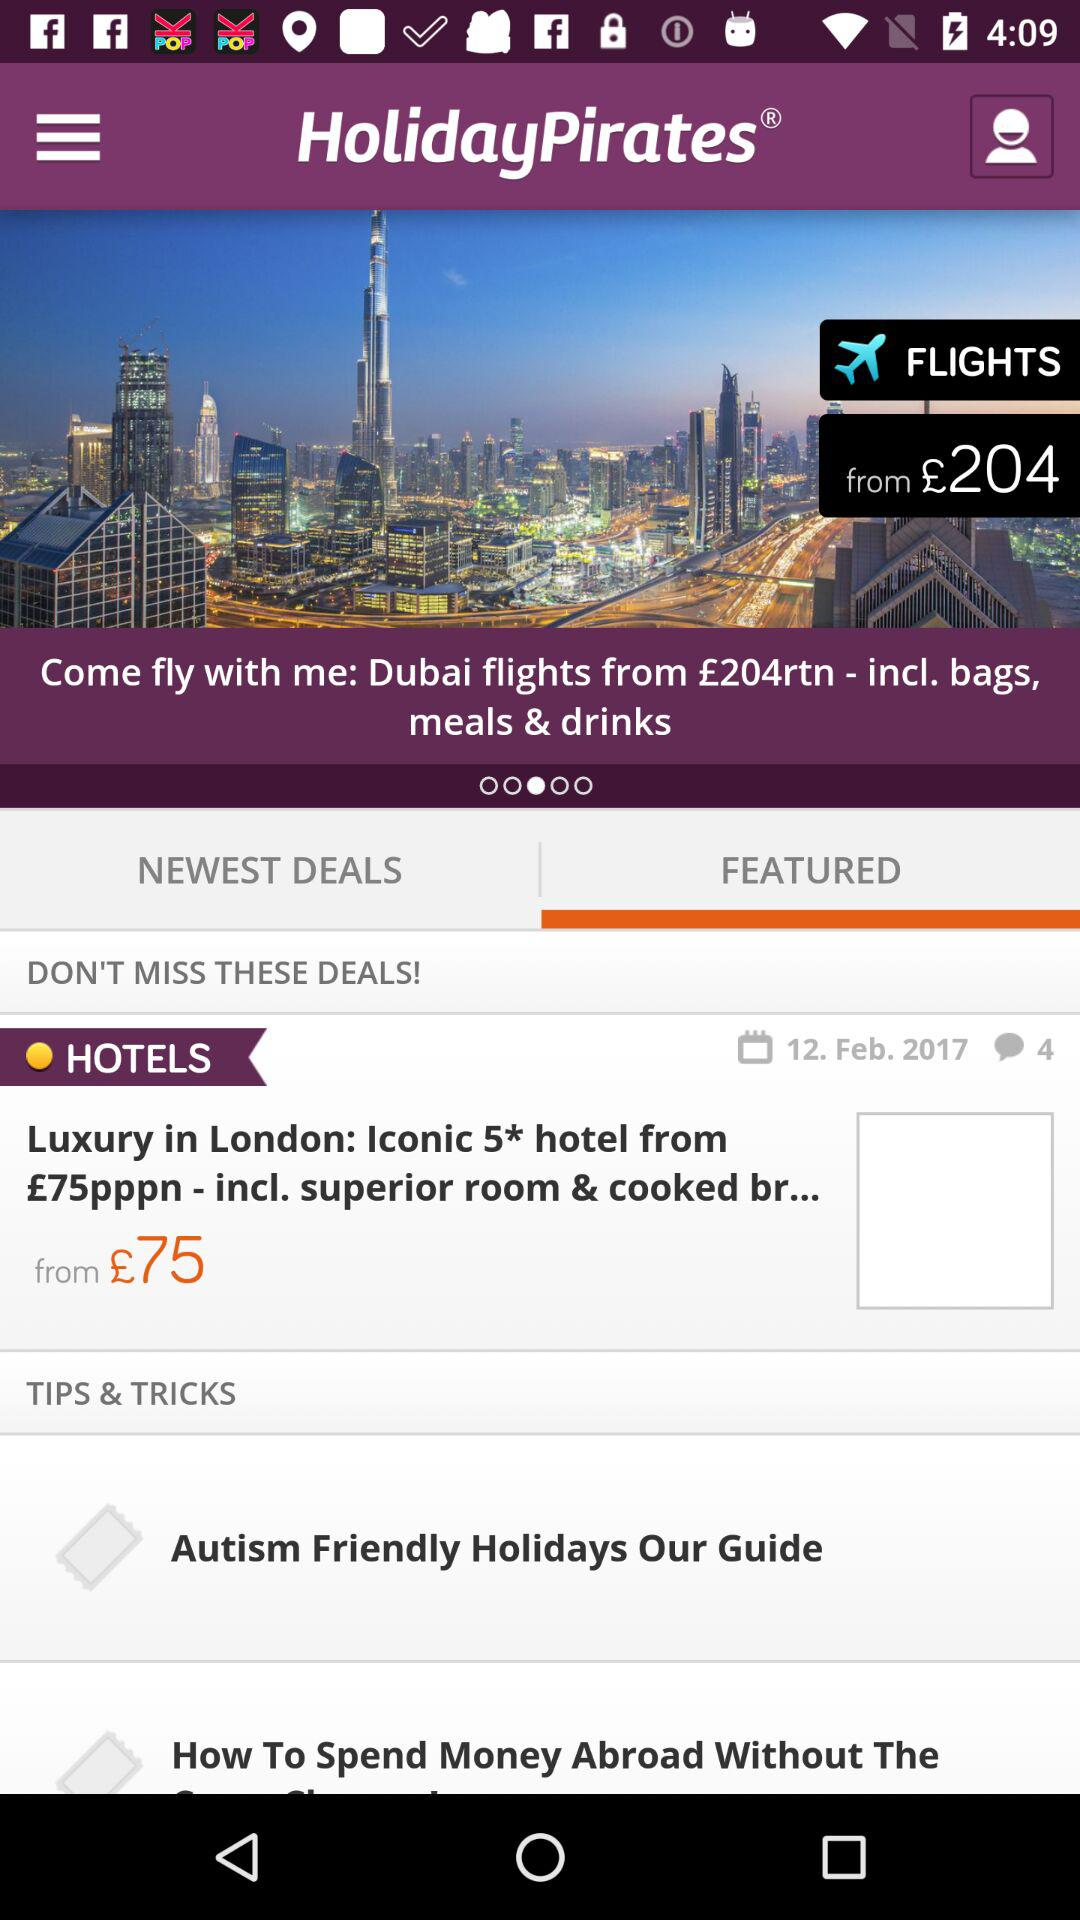What is the date for the hotel deals? The date for the hotel deals is February 12, 2017. 